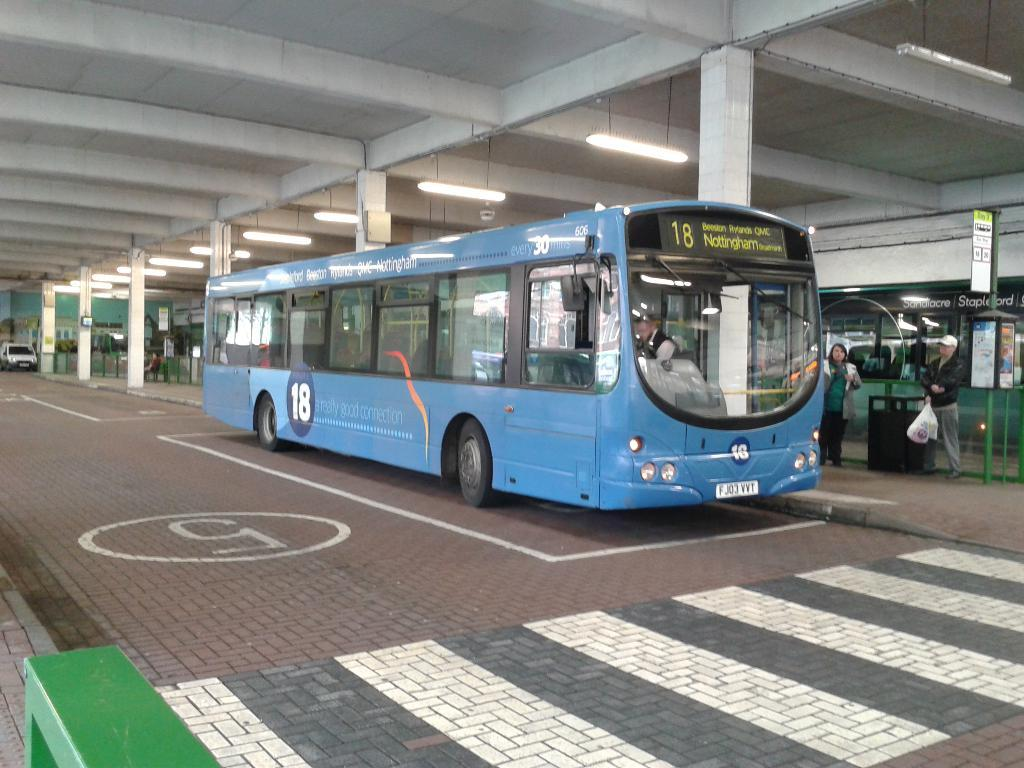<image>
Give a short and clear explanation of the subsequent image. The blue bus has stop 18 next on it's list 